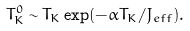Convert formula to latex. <formula><loc_0><loc_0><loc_500><loc_500>T _ { K } ^ { 0 } \sim T _ { K } \exp ( - \alpha T _ { K } / J _ { e f f } ) .</formula> 